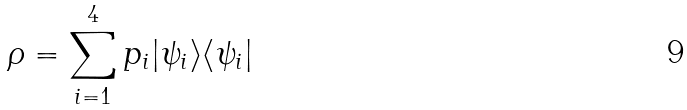Convert formula to latex. <formula><loc_0><loc_0><loc_500><loc_500>\rho = \sum _ { i = 1 } ^ { 4 } p _ { i } | \psi _ { i } \rangle \langle \psi _ { i } |</formula> 